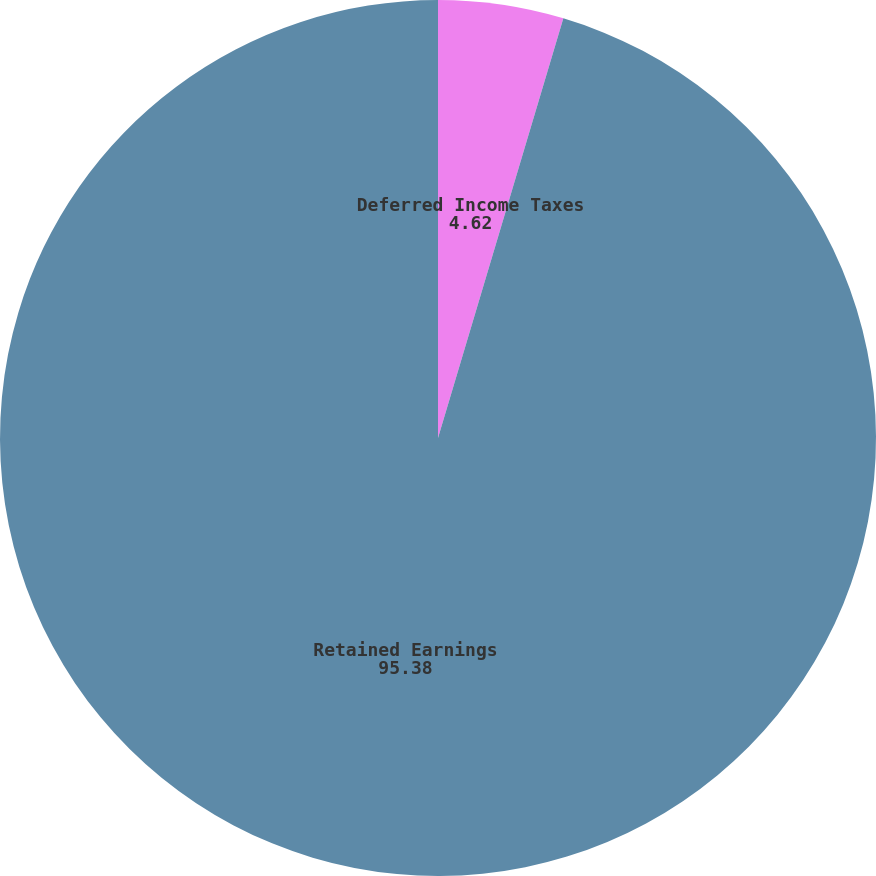Convert chart to OTSL. <chart><loc_0><loc_0><loc_500><loc_500><pie_chart><fcel>Deferred Income Taxes<fcel>Retained Earnings<nl><fcel>4.62%<fcel>95.38%<nl></chart> 